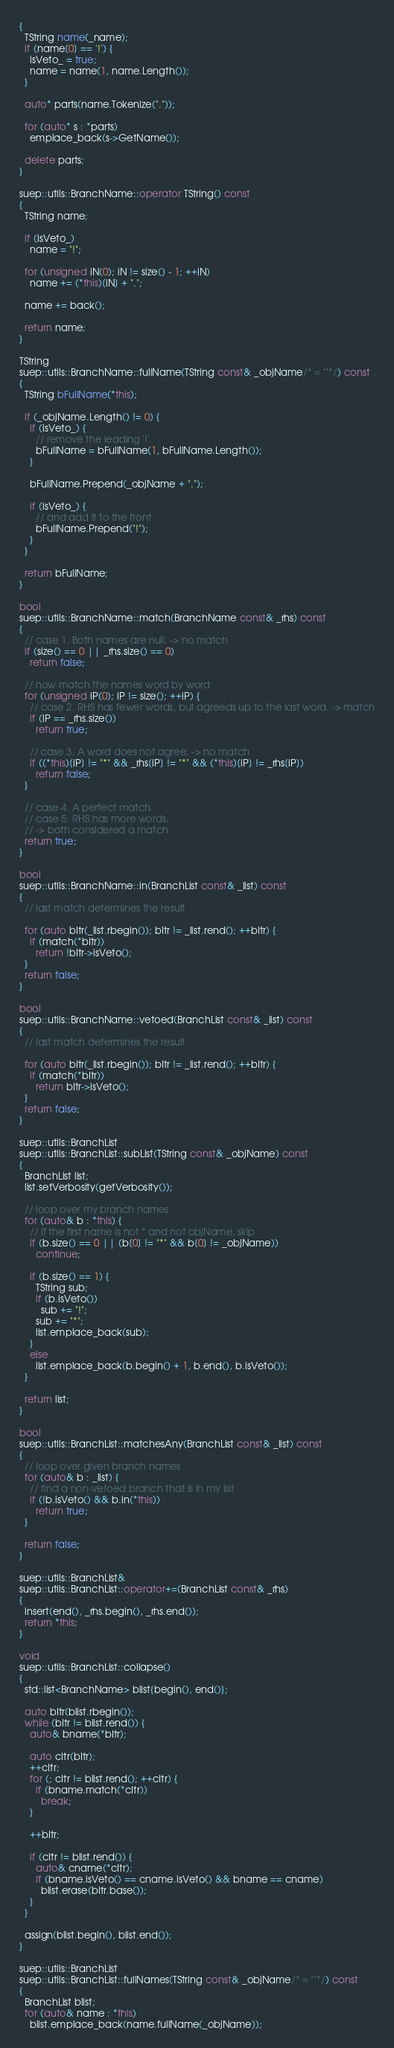<code> <loc_0><loc_0><loc_500><loc_500><_C++_>{
  TString name(_name);
  if (name[0] == '!') {
    isVeto_ = true;
    name = name(1, name.Length());
  }

  auto* parts(name.Tokenize("."));

  for (auto* s : *parts)
    emplace_back(s->GetName());

  delete parts;
}

suep::utils::BranchName::operator TString() const
{
  TString name;

  if (isVeto_)
    name = "!";

  for (unsigned iN(0); iN != size() - 1; ++iN)
    name += (*this)[iN] + ".";

  name += back();

  return name;
}

TString
suep::utils::BranchName::fullName(TString const& _objName/* = ""*/) const
{
  TString bFullName(*this);

  if (_objName.Length() != 0) {
    if (isVeto_) {
      // remove the leading '!'
      bFullName = bFullName(1, bFullName.Length());
    }
    
    bFullName.Prepend(_objName + ".");

    if (isVeto_) {
      // and add it to the front
      bFullName.Prepend("!");
    }
  }

  return bFullName;
}

bool
suep::utils::BranchName::match(BranchName const& _rhs) const
{
  // case 1. Both names are null. -> no match
  if (size() == 0 || _rhs.size() == 0)
    return false;

  // now match the names word by word
  for (unsigned iP(0); iP != size(); ++iP) {
    // case 2. RHS has fewer words, but agreeds up to the last word. -> match
    if (iP == _rhs.size())
      return true;

    // case 3. A word does not agree. -> no match
    if ((*this)[iP] != "*" && _rhs[iP] != "*" && (*this)[iP] != _rhs[iP])
      return false;
  }
        
  // case 4. A perfect match.
  // case 5. RHS has more words.
  // -> both considered a match
  return true;
}

bool
suep::utils::BranchName::in(BranchList const& _list) const
{
  // last match determines the result

  for (auto bItr(_list.rbegin()); bItr != _list.rend(); ++bItr) {
    if (match(*bItr))
      return !bItr->isVeto();
  }
  return false;
}

bool
suep::utils::BranchName::vetoed(BranchList const& _list) const
{
  // last match determines the result

  for (auto bItr(_list.rbegin()); bItr != _list.rend(); ++bItr) {
    if (match(*bItr))
      return bItr->isVeto();
  }
  return false;
}

suep::utils::BranchList
suep::utils::BranchList::subList(TString const& _objName) const
{
  BranchList list;
  list.setVerbosity(getVerbosity());

  // loop over my branch names
  for (auto& b : *this) {
    // if the first name is not * and not objName, skip
    if (b.size() == 0 || (b[0] != "*" && b[0] != _objName))
      continue;

    if (b.size() == 1) {
      TString sub;
      if (b.isVeto())
        sub += "!";
      sub += "*";
      list.emplace_back(sub);
    }
    else
      list.emplace_back(b.begin() + 1, b.end(), b.isVeto());
  }

  return list;
}

bool
suep::utils::BranchList::matchesAny(BranchList const& _list) const
{
  // loop over given branch names
  for (auto& b : _list) {
    // find a non-vetoed branch that is in my list
    if (!b.isVeto() && b.in(*this))
      return true;
  }

  return false;
}

suep::utils::BranchList&
suep::utils::BranchList::operator+=(BranchList const& _rhs)
{
  insert(end(), _rhs.begin(), _rhs.end());
  return *this;
}

void
suep::utils::BranchList::collapse()
{
  std::list<BranchName> blist{begin(), end()};

  auto bItr(blist.rbegin());
  while (bItr != blist.rend()) {
    auto& bname(*bItr);

    auto cItr(bItr);
    ++cItr;
    for (; cItr != blist.rend(); ++cItr) {
      if (bname.match(*cItr))
        break;
    }

    ++bItr;
    
    if (cItr != blist.rend()) {
      auto& cname(*cItr);
      if (bname.isVeto() == cname.isVeto() && bname == cname)
        blist.erase(bItr.base());
    }
  }

  assign(blist.begin(), blist.end());
}

suep::utils::BranchList
suep::utils::BranchList::fullNames(TString const& _objName/* = ""*/) const
{
  BranchList blist;
  for (auto& name : *this)
    blist.emplace_back(name.fullName(_objName));
</code> 